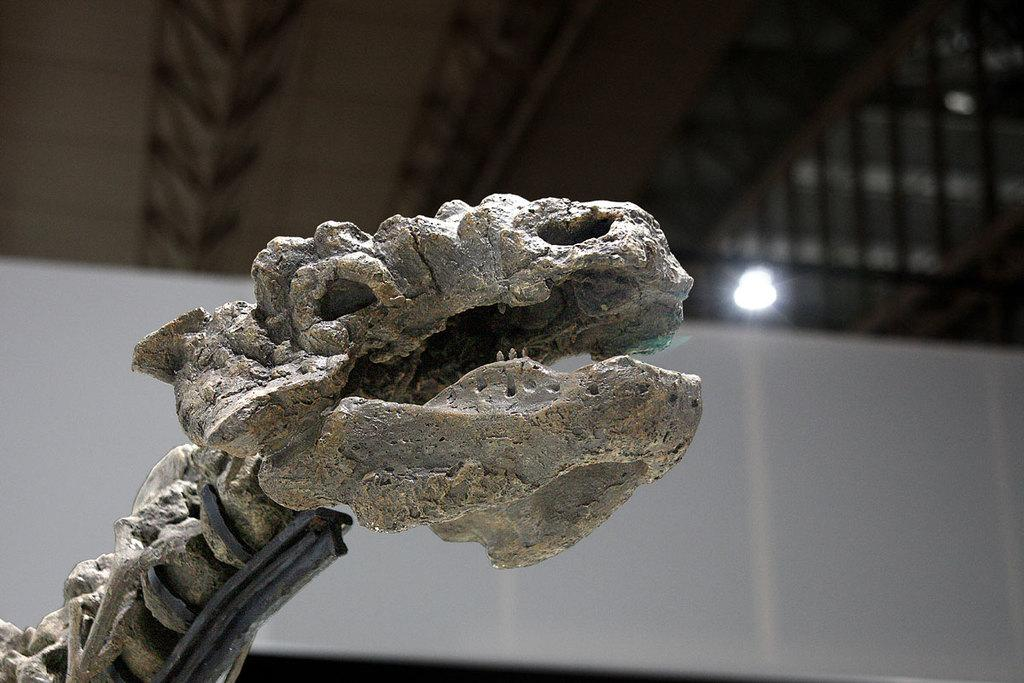What is the main subject of the image? There is a dinosaur skeleton in the image. What can be seen in the background of the image? There is light visible in the background of the image. What other object is present in the image? There is a white cloth in the image. What type of observation error can be seen in the image? There is no observation error present in the image; it is a clear depiction of a dinosaur skeleton, light, and a white cloth. 